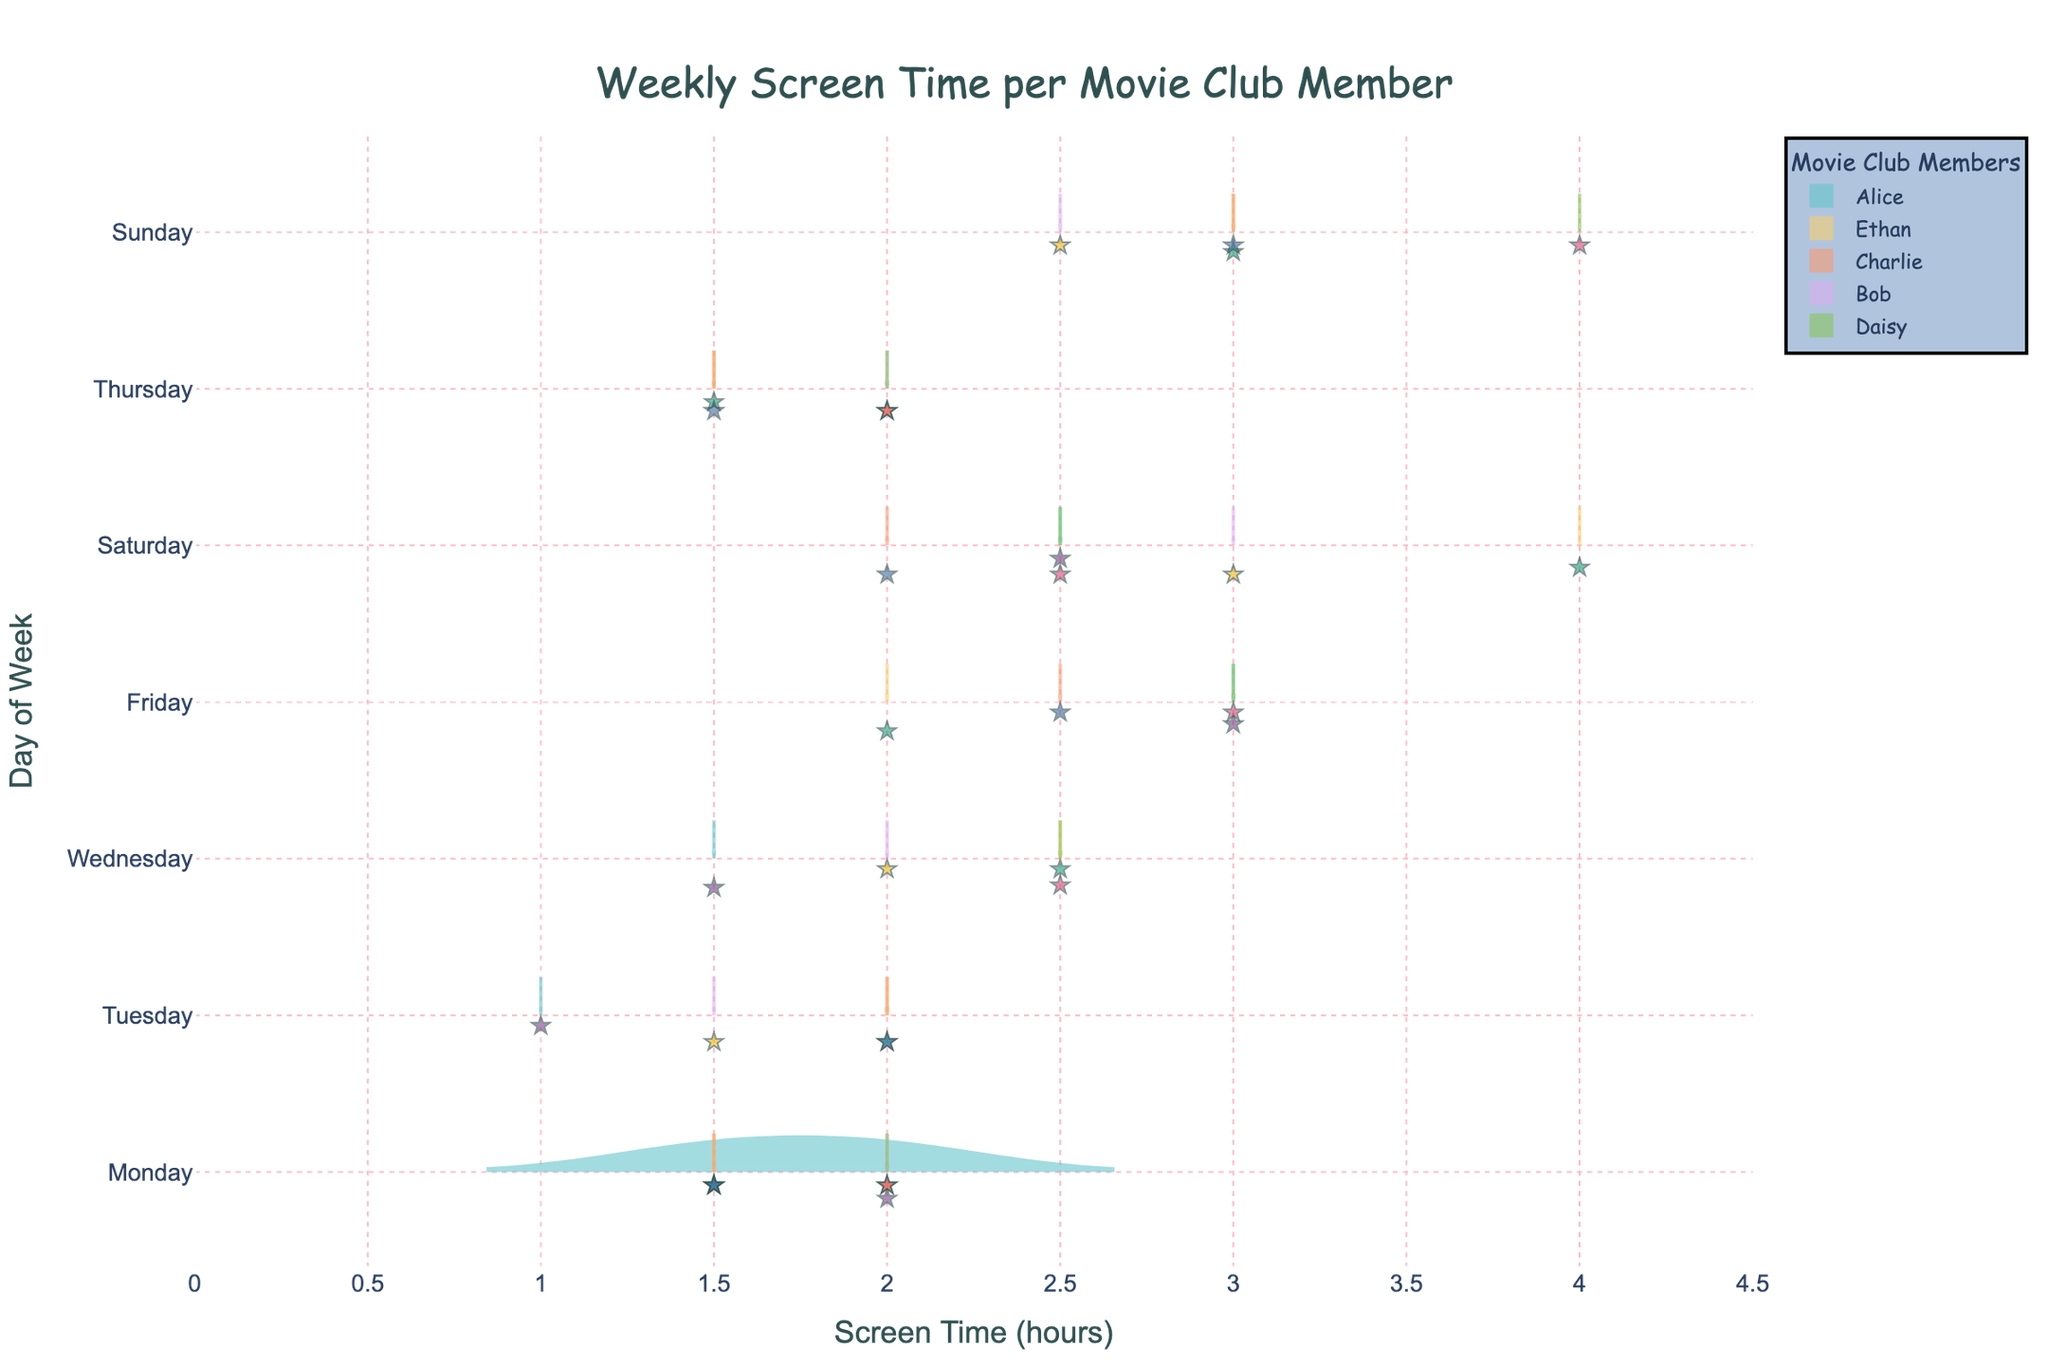What is the title of the chart? The title of the chart is located at the top and it reads: "Weekly Screen Time per Movie Club Member".
Answer: Weekly Screen Time per Movie Club Member How many members are displayed in the chart? The chart has different violins for each member, and five names (Alice, Bob, Charlie, Daisy, and Ethan) are included in the legend.
Answer: 5 Which member has the highest recorded screen time on Sunday? To determine who has the highest screen time on Sunday, look at the violins corresponding to Sunday and compare the maximum screen time for each member. Daisy has 4 hours on Sunday, which is the highest.
Answer: Daisy On which day does Alice have the highest screen time, and how much is it? To find this, look at the violin plot for Alice across different days. Friday shows the highest screen time with 3 hours.
Answer: Friday, 3 hours Which day of the week shows the most variation in screen time across all members? By looking for the day with the widest spread of values in the violins, we see that Saturday (with ranges from 2.5 to 4 hours) shows the most variation.
Answer: Saturday What is the average screen time for Ethan? Ethan's screen time values across days are summed and divided by the number of recorded days (total). The values are 1.5, 2, 2.5, 1.5, 2, 4, and 3, which sum to 16.5. There are 7 entries, so 16.5/7.
Answer: 2.36 hours Who has the lowest screen time on Wednesday? By comparing the Wednesday data points for each member, we see Alice with 1.5 hours, Bob with 2 hours, Daisy with 2.5 hours, and Ethan with 2.5 hours. Charlie does not have data for Wednesday. Thus, Alice has the lowest screen time.
Answer: Alice Which day has the least screen time for Bob, and what is it? For Bob, locate the day with the smallest screen time within Bob's violin plots. It's Tuesday with 1.5 hours.
Answer: Tuesday, 1.5 hours 